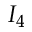<formula> <loc_0><loc_0><loc_500><loc_500>I _ { 4 }</formula> 